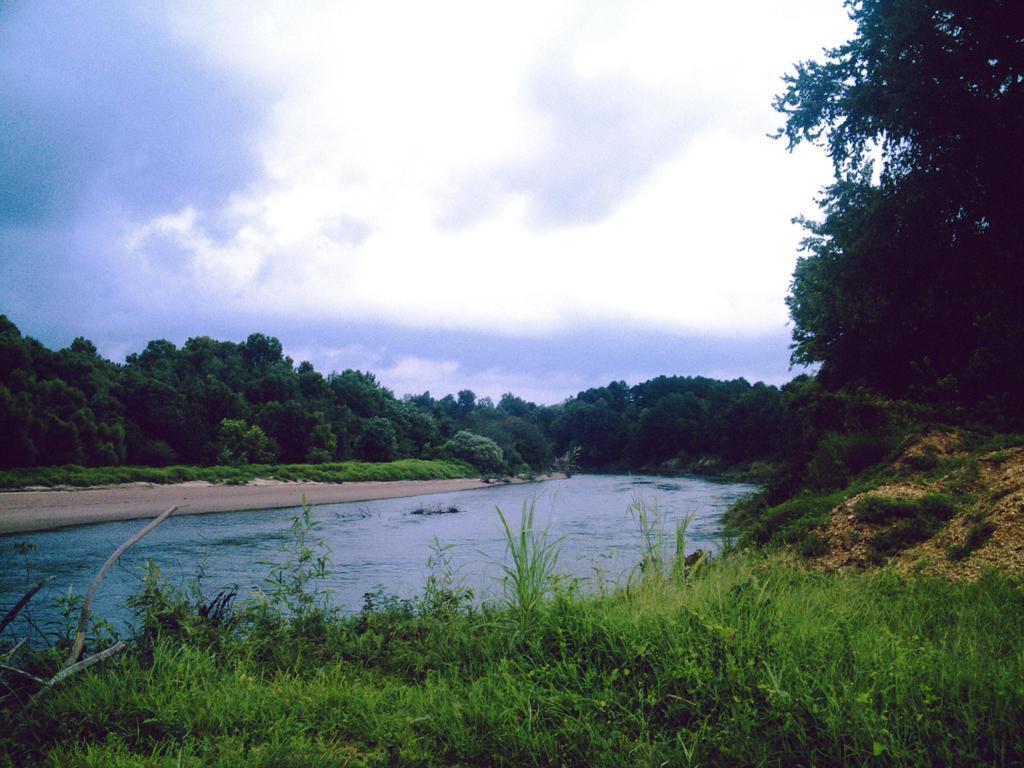Could you give a brief overview of what you see in this image? In this picture we can see trees and water. At the bottom of the image, there is grass. At the top of the image, there is the cloudy sky. 